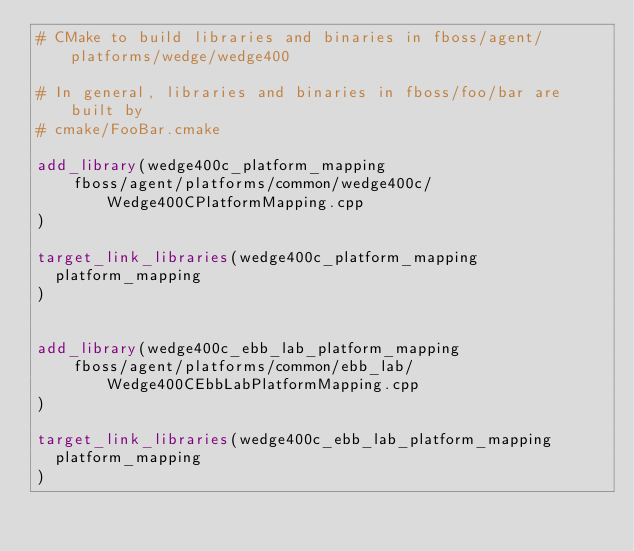Convert code to text. <code><loc_0><loc_0><loc_500><loc_500><_CMake_># CMake to build libraries and binaries in fboss/agent/platforms/wedge/wedge400

# In general, libraries and binaries in fboss/foo/bar are built by
# cmake/FooBar.cmake

add_library(wedge400c_platform_mapping
    fboss/agent/platforms/common/wedge400c/Wedge400CPlatformMapping.cpp
)

target_link_libraries(wedge400c_platform_mapping
  platform_mapping
)


add_library(wedge400c_ebb_lab_platform_mapping
    fboss/agent/platforms/common/ebb_lab/Wedge400CEbbLabPlatformMapping.cpp
)

target_link_libraries(wedge400c_ebb_lab_platform_mapping
  platform_mapping
)
</code> 